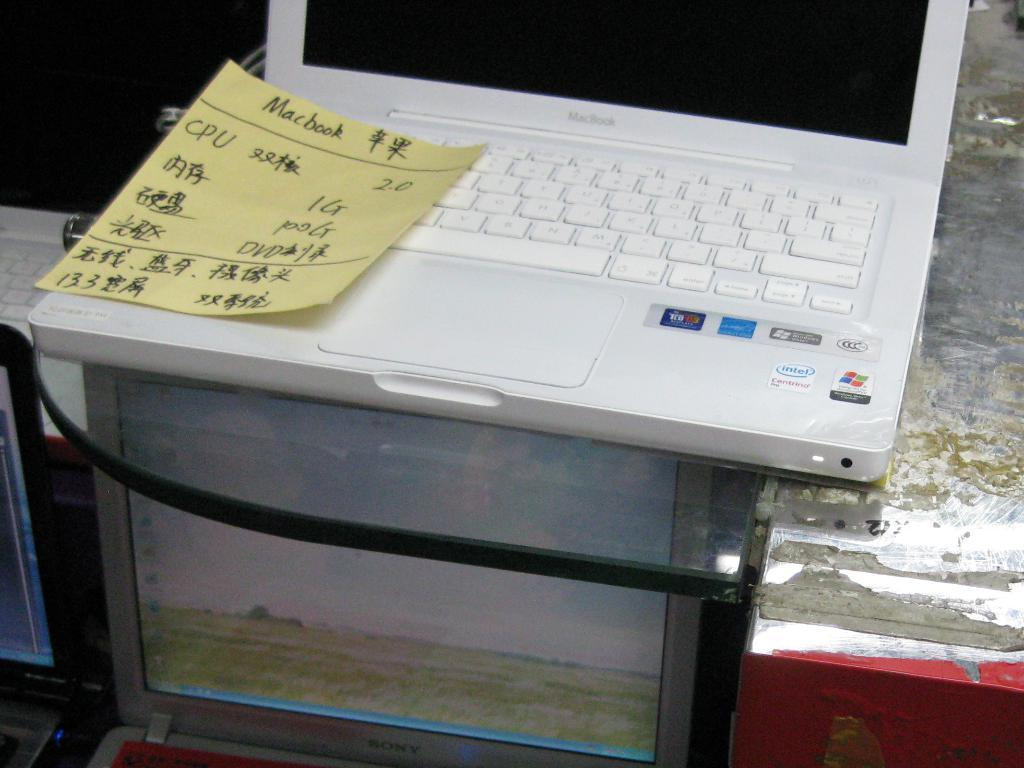What electronic devices are present in the image? There are laptops in the image. What type of paper can be seen in the image? There is a yellow paper with text in the image. On which laptop is the yellow paper placed? The yellow paper is on a white laptop. Can you describe the object visible on the right side of the image? Unfortunately, the provided facts do not give any information about the object on the right side of the image. How many women are present in the image? There is no information about women in the provided facts, so we cannot determine the number of women in the image. 